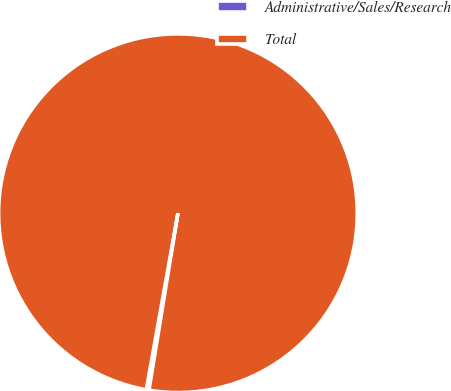<chart> <loc_0><loc_0><loc_500><loc_500><pie_chart><fcel>Administrative/Sales/Research<fcel>Total<nl><fcel>0.24%<fcel>99.76%<nl></chart> 